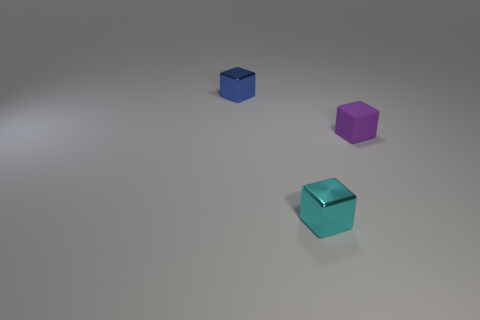Add 3 small cyan cubes. How many objects exist? 6 Subtract all small blue blocks. Subtract all tiny brown matte blocks. How many objects are left? 2 Add 1 purple objects. How many purple objects are left? 2 Add 2 blocks. How many blocks exist? 5 Subtract 0 yellow cubes. How many objects are left? 3 